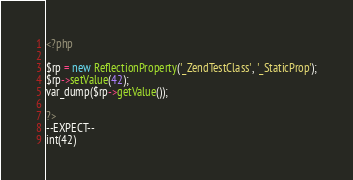Convert code to text. <code><loc_0><loc_0><loc_500><loc_500><_PHP_><?php

$rp = new ReflectionProperty('_ZendTestClass', '_StaticProp');
$rp->setValue(42);
var_dump($rp->getValue());

?>
--EXPECT--
int(42)
</code> 